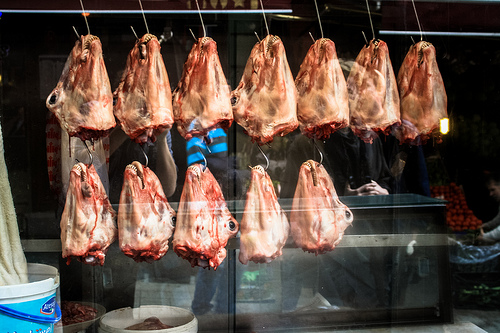<image>
Is the meat next to the meat? No. The meat is not positioned next to the meat. They are located in different areas of the scene. 